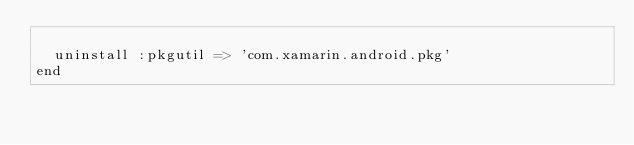<code> <loc_0><loc_0><loc_500><loc_500><_Ruby_>
  uninstall :pkgutil => 'com.xamarin.android.pkg'
end
</code> 